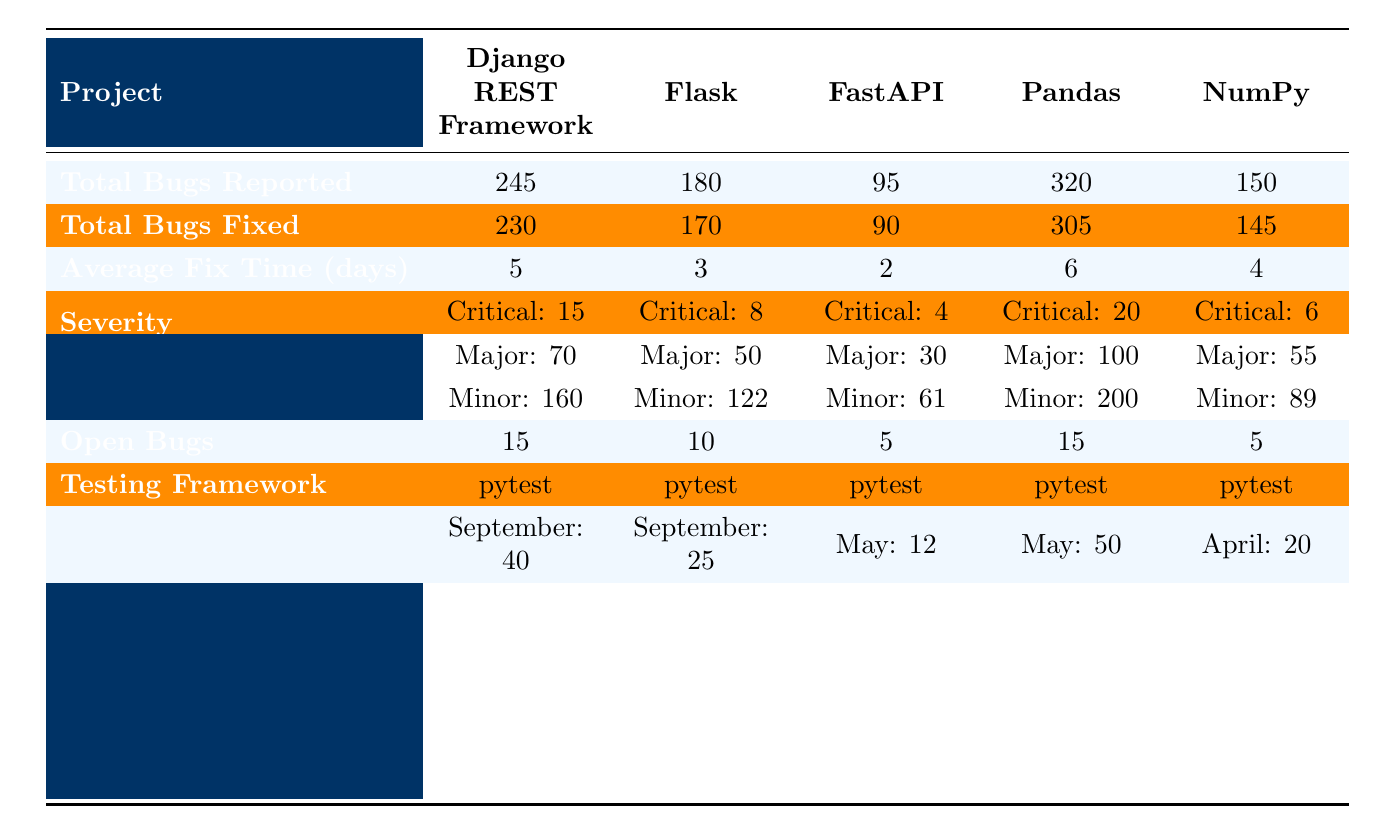What is the project with the highest number of total bugs reported? The table shows that the project with the highest total bugs reported is "Pandas" with 320 bugs.
Answer: Pandas How many total bugs were fixed in the Flask project? According to the table, Flask has a total of 170 bugs fixed.
Answer: 170 What is the average fix time for FastAPI? The average fix time for FastAPI is shown as 2 days in the table.
Answer: 2 days Which project has the most open bugs? Both Django REST Framework and Pandas have the same number of open bugs, which is 15.
Answer: Django REST Framework and Pandas Which severity category has the highest count in the Django REST Framework? The severity distribution for Django REST Framework indicates that 'Minor' has the highest count with 160.
Answer: Minor How many total bugs were reported across all projects? The total bugs reported can be calculated by summing the individual totals: 245 + 180 + 95 + 320 + 150 = 990.
Answer: 990 What is the difference in average fix time between Flask and Pandas? Flask has an average fix time of 3 days and Pandas has 6 days. The difference is 6 - 3 = 3 days.
Answer: 3 days True or False: FastAPI has more total bugs fixed than open bugs. FastAPI has 90 bugs fixed and 5 open bugs, so the statement is True.
Answer: True Which project had the maximum number of bugs reported in a single month and in which month was it? The project with the most bugs reported in a month is Django REST Framework with 40 bugs in September.
Answer: Django REST Framework in September If we compare the total bugs fixed for NumPy and FastAPI, how many more bugs were fixed in NumPy? NumPy fixed 145 bugs while FastAPI fixed 90 bugs. The difference is 145 - 90 = 55.
Answer: 55 Which testing framework is used by all projects? All projects listed in the table use "pytest" as their testing framework.
Answer: pytest 